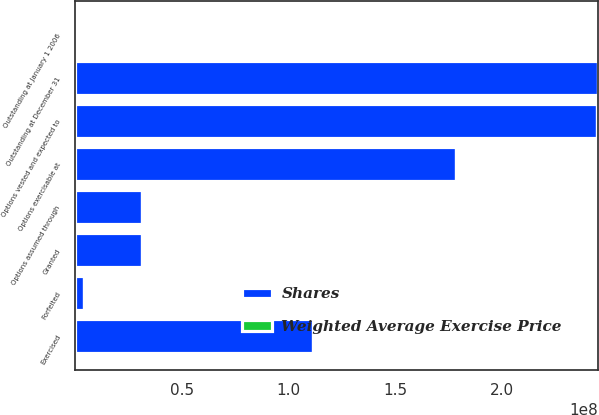Convert chart. <chart><loc_0><loc_0><loc_500><loc_500><stacked_bar_chart><ecel><fcel>Outstanding at January 1 2006<fcel>Options assumed through<fcel>Granted<fcel>Exercised<fcel>Forfeited<fcel>Outstanding at December 31<fcel>Options exercisable at<fcel>Options vested and expected to<nl><fcel>Shares<fcel>44.42<fcel>3.15063e+07<fcel>3.15342e+07<fcel>1.11615e+08<fcel>4.48499e+06<fcel>2.45073e+08<fcel>1.78277e+08<fcel>2.44223e+08<nl><fcel>Weighted Average Exercise Price<fcel>35.13<fcel>32.7<fcel>44.42<fcel>32.93<fcel>41.48<fcel>36.89<fcel>34.17<fcel>36.87<nl></chart> 